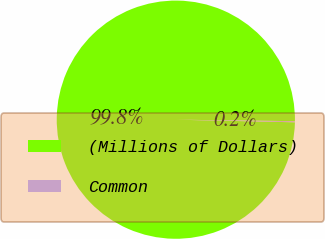Convert chart. <chart><loc_0><loc_0><loc_500><loc_500><pie_chart><fcel>(Millions of Dollars)<fcel>Common<nl><fcel>99.85%<fcel>0.15%<nl></chart> 